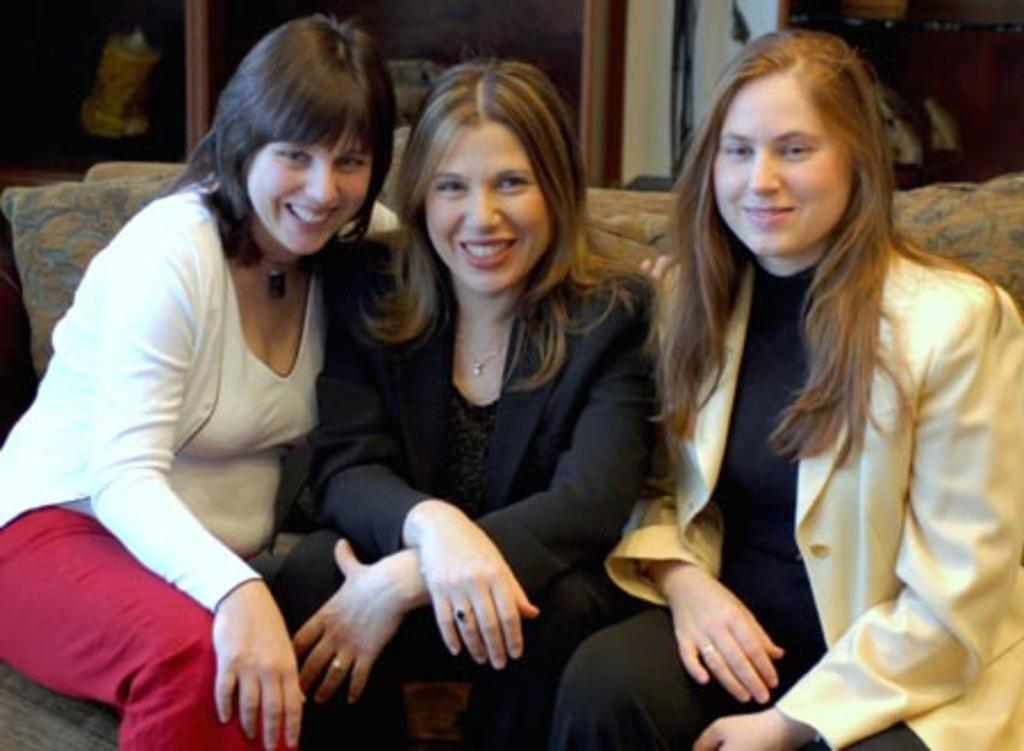How many people are in the image? There are three women in the image. What are the women doing in the image? The women are sitting on a sofa. What type of pancake is the woman on the left eating in the image? There is no pancake present in the image, and the women are not eating anything. 